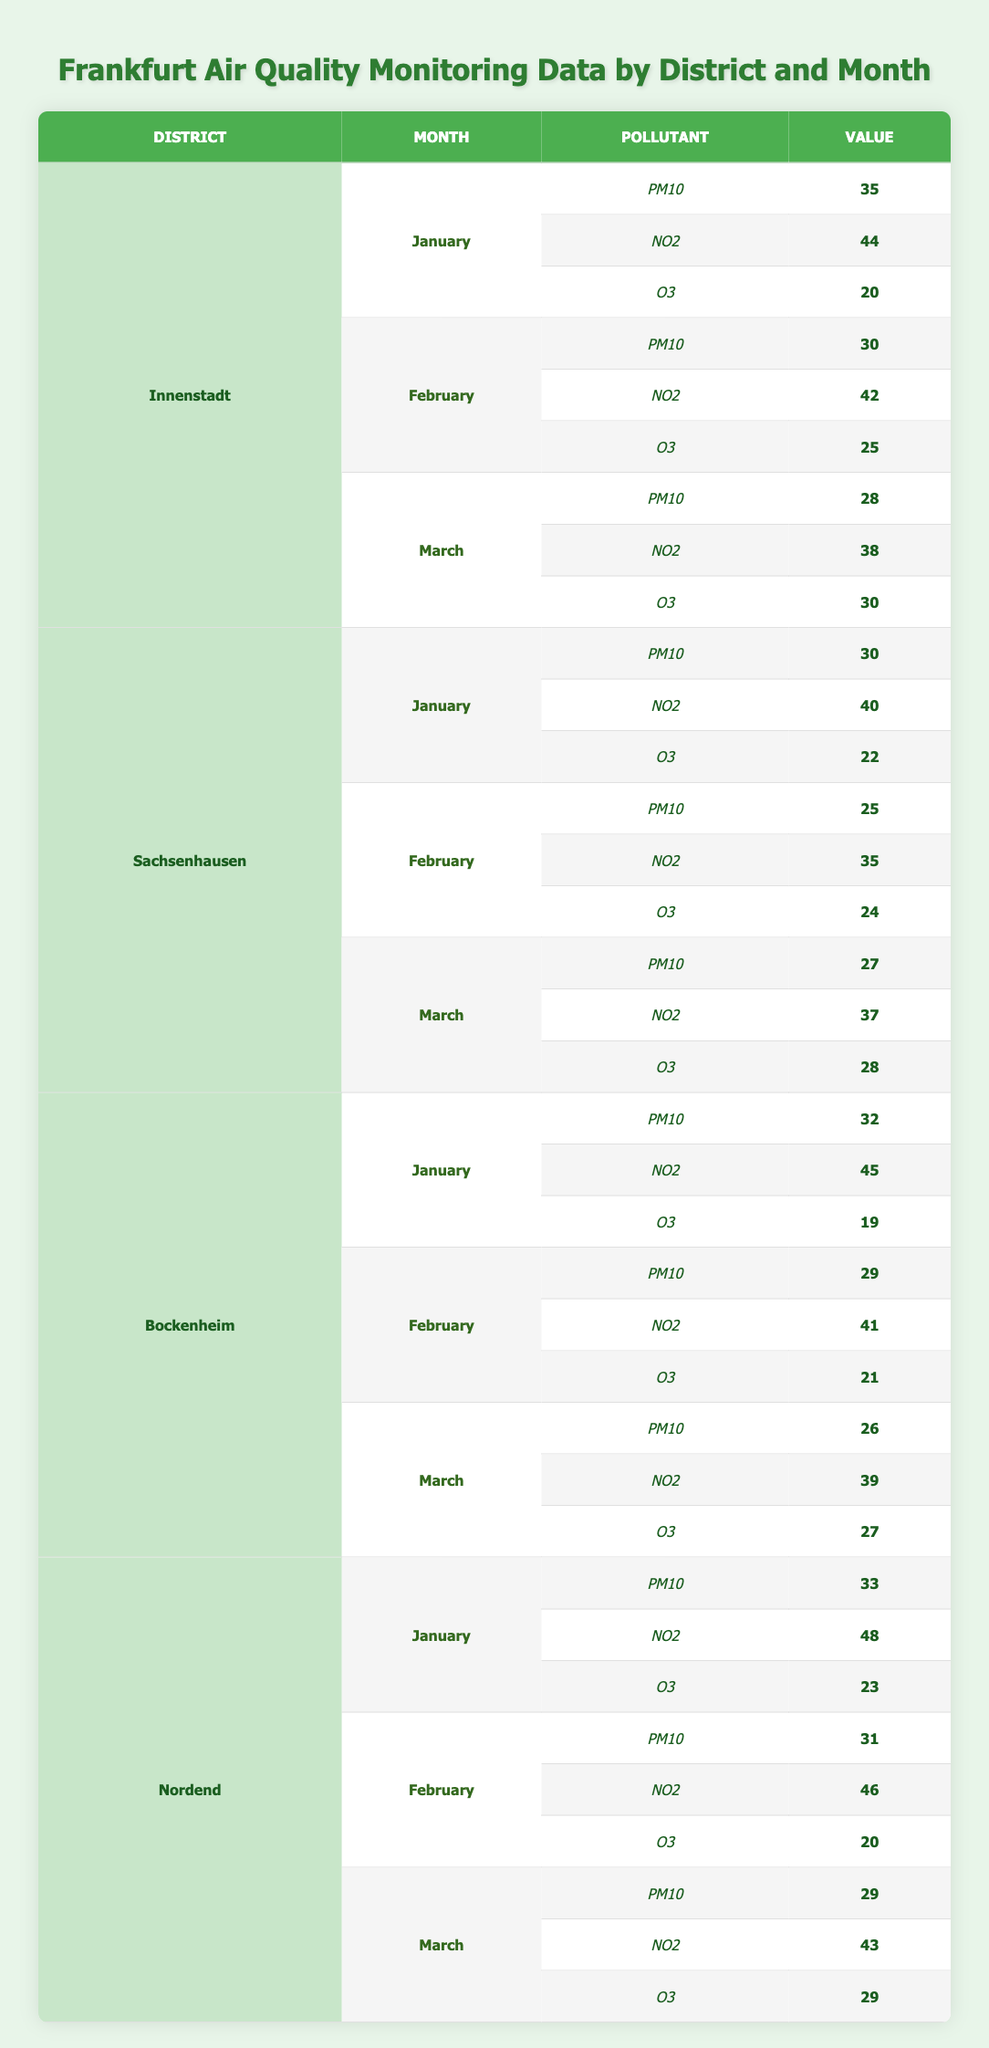What is the PM10 value for Innenstadt in January? The table shows that for the district Innenstadt in January, the PM10 value is provided in the row corresponding to January under the pollutant column for PM10. Referring to that row, we find that the value is 35.
Answer: 35 Which district has the highest NO2 reading in February? To determine which district has the highest NO2 reading in February, we look at the NO2 values under the month of February for each district: Innenstadt (42), Sachsenhausen (35), Bockenheim (41), and Nordend (46). Comparing these values, Nordend has the highest NO2 reading at 46.
Answer: Nordend What is the average O3 value for Bockenheim across the three months? We need to find the O3 values for Bockenheim for each month: January (19), February (21), and March (27). We sum these values: 19 + 21 + 27 = 67. Then, we divide by the number of months (3) to find the average: 67 / 3 = 22.33.
Answer: 22.33 Is the PM10 value in March higher in Sachsenhausen than in Innenstadt? We first retrieve the PM10 values for both districts in March: Sachsenhausen has a value of 27, while Innenstadt has a value of 28. Since 27 is less than 28, the PM10 value in Sachsenhausen is not higher than in Innenstadt.
Answer: No What is the total NO2 value for all districts in January? We need to gather the NO2 values for each district in January: Innenstadt (44), Sachsenhausen (40), Bockenheim (45), and Nordend (48). Summing these gives us: 44 + 40 + 45 + 48 = 177.
Answer: 177 